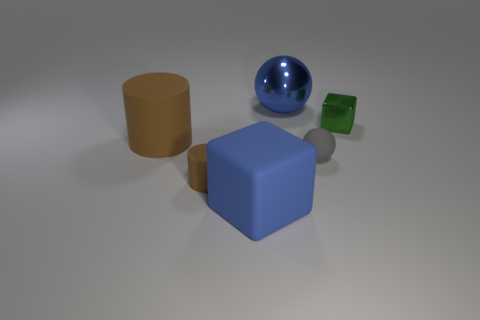What is the size of the block that is the same color as the large metallic sphere?
Ensure brevity in your answer.  Large. What number of green blocks have the same material as the large brown thing?
Your answer should be compact. 0. What is the color of the big object left of the big object in front of the big brown cylinder?
Your response must be concise. Brown. What number of objects are either gray matte spheres or spheres that are in front of the green object?
Provide a succinct answer. 1. Are there any shiny balls that have the same color as the matte block?
Make the answer very short. Yes. What number of blue things are large shiny spheres or cubes?
Ensure brevity in your answer.  2. How many other things are the same size as the gray object?
Ensure brevity in your answer.  2. How many small objects are either yellow shiny cubes or rubber blocks?
Ensure brevity in your answer.  0. Do the blue metal ball and the ball in front of the metal cube have the same size?
Provide a short and direct response. No. How many other things are the same shape as the small brown thing?
Provide a succinct answer. 1. 